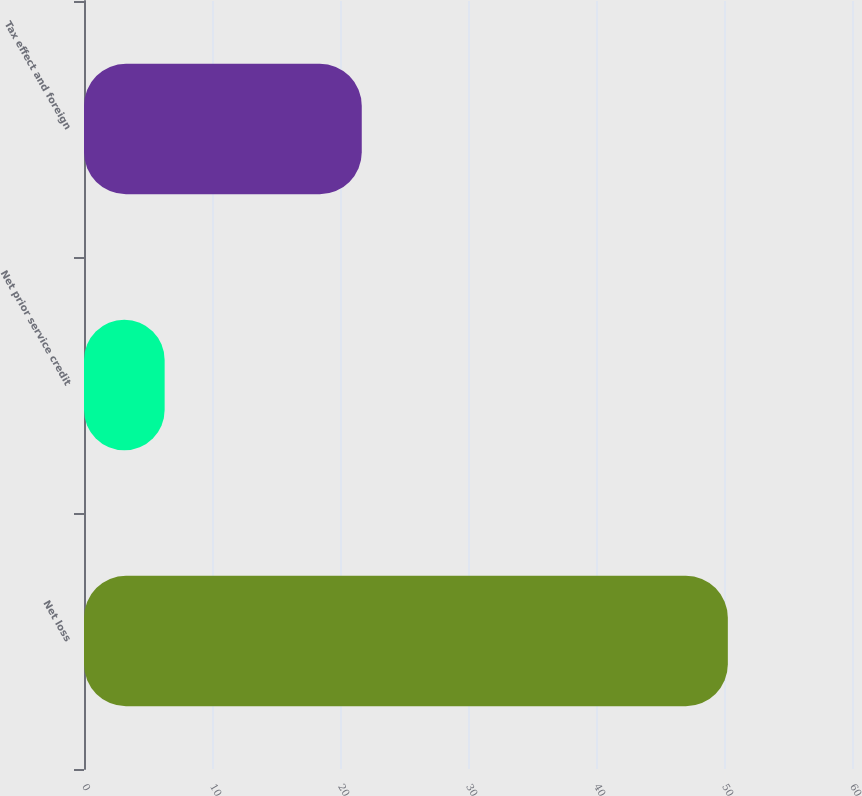<chart> <loc_0><loc_0><loc_500><loc_500><bar_chart><fcel>Net loss<fcel>Net prior service credit<fcel>Tax effect and foreign<nl><fcel>50.3<fcel>6.3<fcel>21.7<nl></chart> 